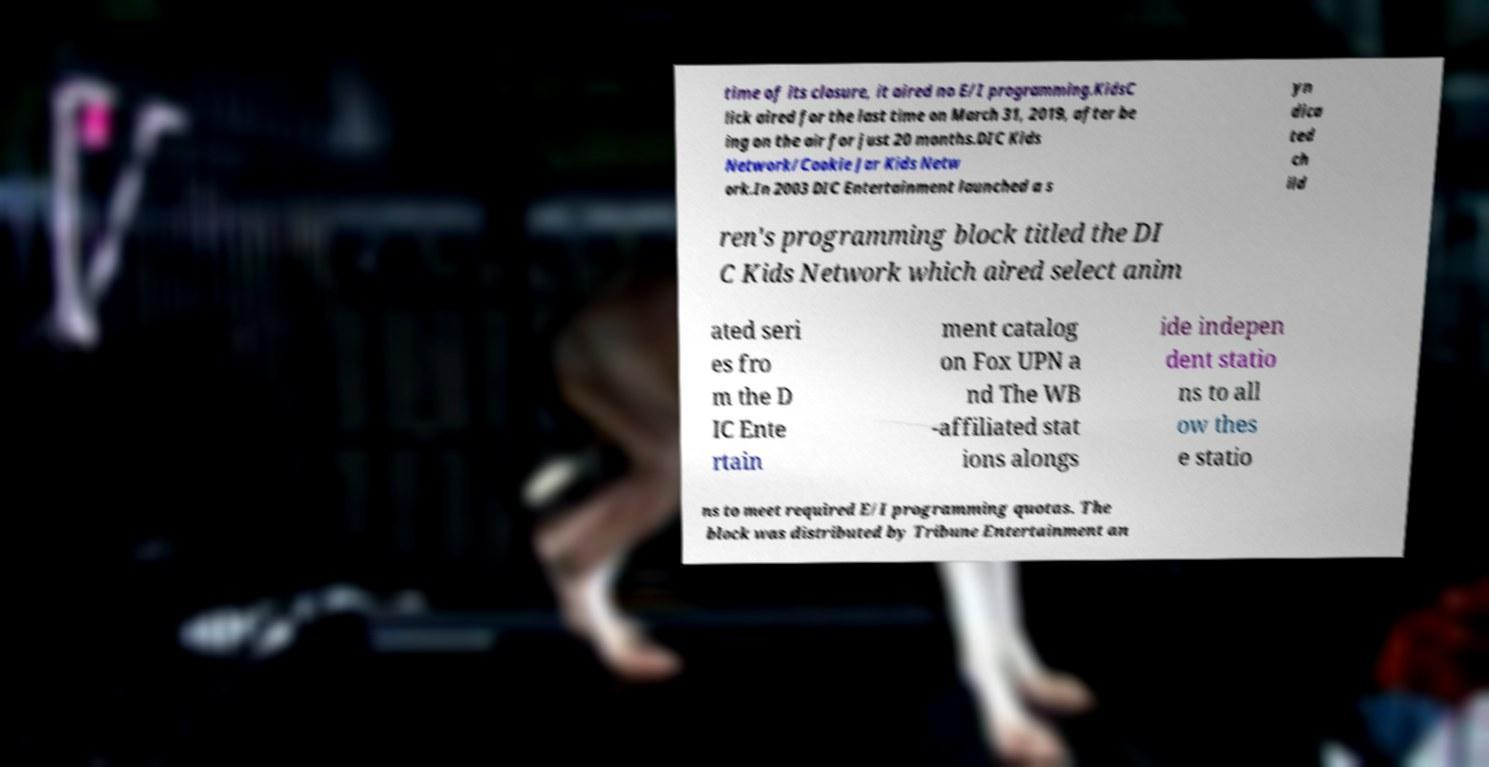Can you read and provide the text displayed in the image?This photo seems to have some interesting text. Can you extract and type it out for me? time of its closure, it aired no E/I programming.KidsC lick aired for the last time on March 31, 2019, after be ing on the air for just 20 months.DIC Kids Network/Cookie Jar Kids Netw ork.In 2003 DIC Entertainment launched a s yn dica ted ch ild ren's programming block titled the DI C Kids Network which aired select anim ated seri es fro m the D IC Ente rtain ment catalog on Fox UPN a nd The WB -affiliated stat ions alongs ide indepen dent statio ns to all ow thes e statio ns to meet required E/I programming quotas. The block was distributed by Tribune Entertainment an 